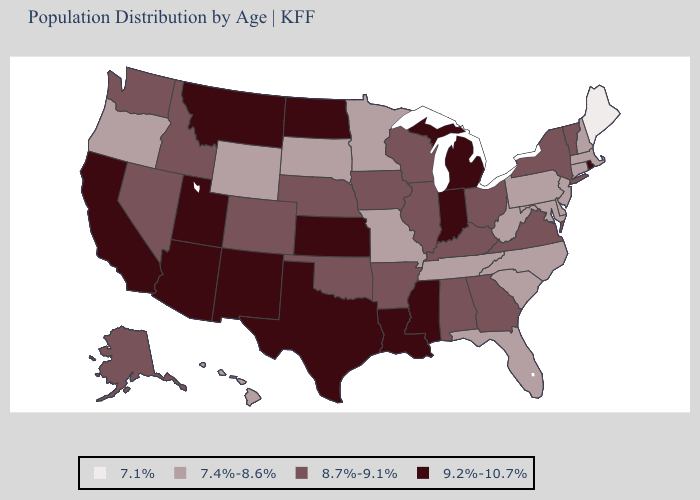Which states have the lowest value in the West?
Give a very brief answer. Hawaii, Oregon, Wyoming. Name the states that have a value in the range 9.2%-10.7%?
Give a very brief answer. Arizona, California, Indiana, Kansas, Louisiana, Michigan, Mississippi, Montana, New Mexico, North Dakota, Rhode Island, Texas, Utah. What is the value of South Carolina?
Answer briefly. 7.4%-8.6%. What is the lowest value in the Northeast?
Answer briefly. 7.1%. What is the value of Maryland?
Answer briefly. 7.4%-8.6%. Is the legend a continuous bar?
Be succinct. No. What is the highest value in states that border Vermont?
Keep it brief. 8.7%-9.1%. Name the states that have a value in the range 8.7%-9.1%?
Write a very short answer. Alabama, Alaska, Arkansas, Colorado, Georgia, Idaho, Illinois, Iowa, Kentucky, Nebraska, Nevada, New York, Ohio, Oklahoma, Vermont, Virginia, Washington, Wisconsin. What is the value of Virginia?
Concise answer only. 8.7%-9.1%. Name the states that have a value in the range 7.4%-8.6%?
Keep it brief. Connecticut, Delaware, Florida, Hawaii, Maryland, Massachusetts, Minnesota, Missouri, New Hampshire, New Jersey, North Carolina, Oregon, Pennsylvania, South Carolina, South Dakota, Tennessee, West Virginia, Wyoming. Among the states that border Mississippi , which have the lowest value?
Short answer required. Tennessee. Does Alaska have a lower value than Kansas?
Be succinct. Yes. Name the states that have a value in the range 8.7%-9.1%?
Keep it brief. Alabama, Alaska, Arkansas, Colorado, Georgia, Idaho, Illinois, Iowa, Kentucky, Nebraska, Nevada, New York, Ohio, Oklahoma, Vermont, Virginia, Washington, Wisconsin. What is the highest value in the USA?
Write a very short answer. 9.2%-10.7%. What is the highest value in the USA?
Short answer required. 9.2%-10.7%. 